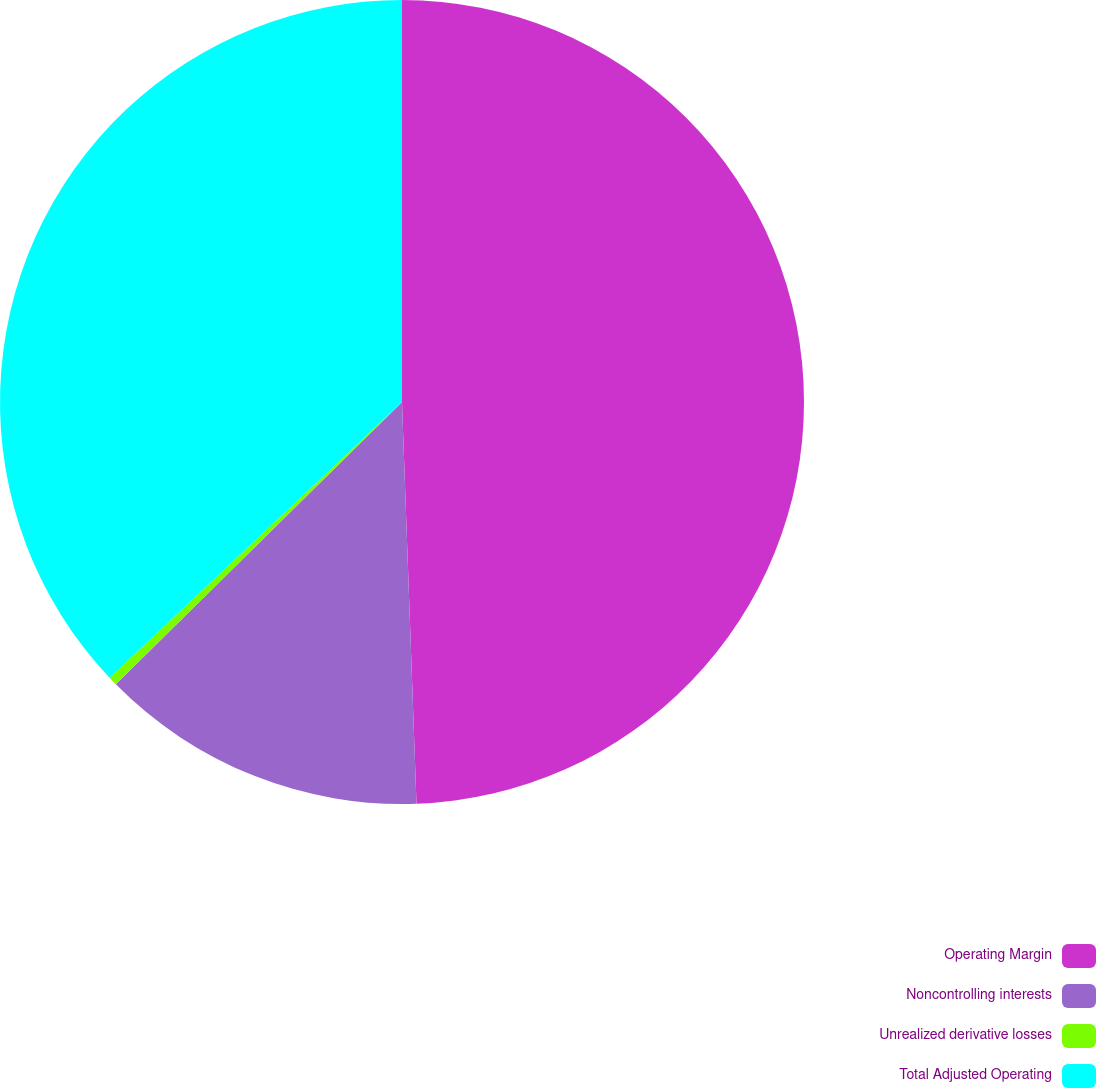<chart> <loc_0><loc_0><loc_500><loc_500><pie_chart><fcel>Operating Margin<fcel>Noncontrolling interests<fcel>Unrealized derivative losses<fcel>Total Adjusted Operating<nl><fcel>49.42%<fcel>13.18%<fcel>0.36%<fcel>37.03%<nl></chart> 